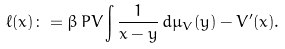Convert formula to latex. <formula><loc_0><loc_0><loc_500><loc_500>\ell ( x ) \colon = \beta \, P V \int \frac { 1 } { x - y } \, d \mu _ { V } ( y ) - V ^ { \prime } ( x ) .</formula> 